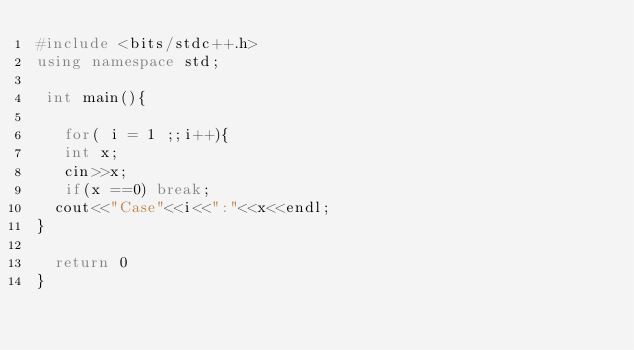Convert code to text. <code><loc_0><loc_0><loc_500><loc_500><_C++_>#include <bits/stdc++.h>
using namespace std;

 int main(){
  
   for( i = 1 ;;i++){
   int x;
   cin>>x;
   if(x ==0) break;
  cout<<"Case"<<i<<":"<<x<<endl;
}

  return 0
}
</code> 